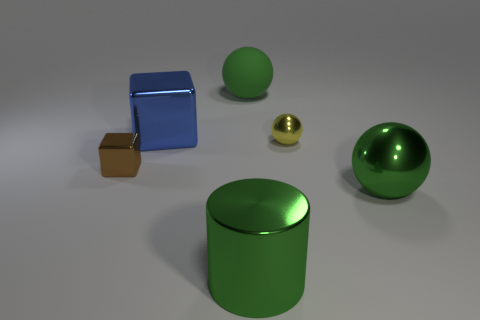Subtract all big green rubber spheres. How many spheres are left? 2 Subtract all blue blocks. How many blocks are left? 1 Add 3 tiny red matte spheres. How many objects exist? 9 Subtract 1 cylinders. How many cylinders are left? 0 Subtract all cylinders. How many objects are left? 5 Subtract all brown cylinders. Subtract all green spheres. How many cylinders are left? 1 Subtract all purple blocks. How many yellow balls are left? 1 Add 6 blue metal blocks. How many blue metal blocks exist? 7 Subtract 1 green cylinders. How many objects are left? 5 Subtract all small brown rubber spheres. Subtract all green rubber balls. How many objects are left? 5 